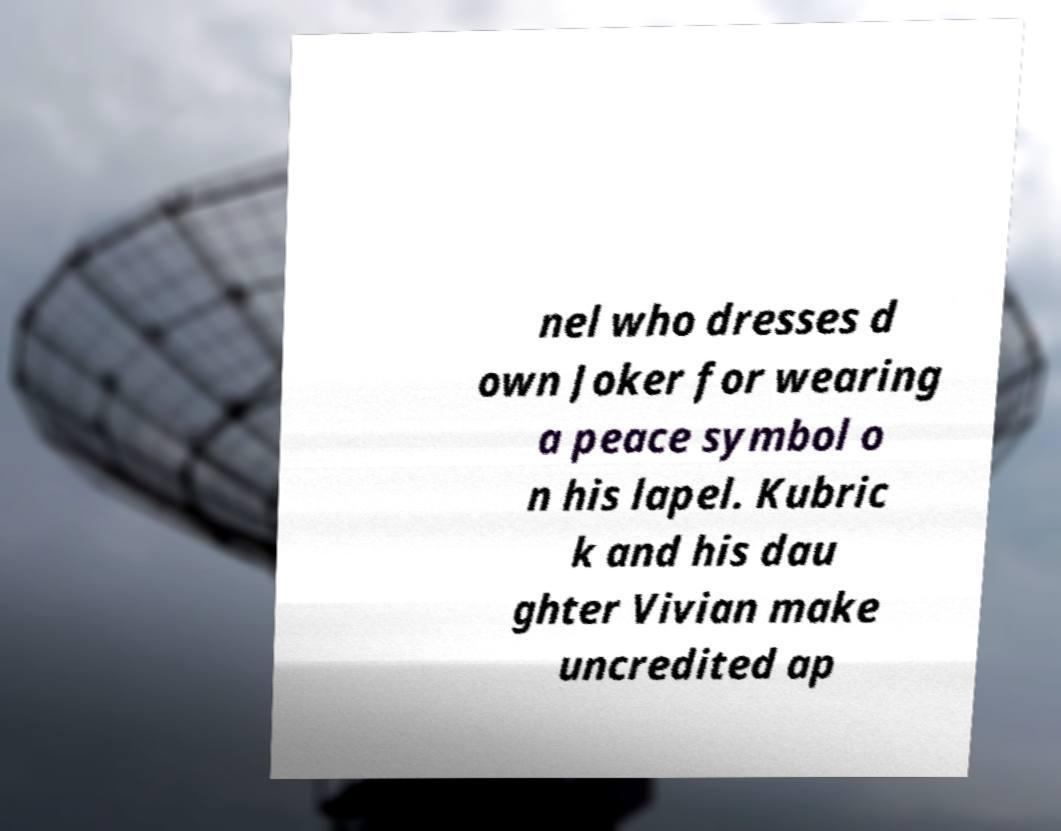Please read and relay the text visible in this image. What does it say? nel who dresses d own Joker for wearing a peace symbol o n his lapel. Kubric k and his dau ghter Vivian make uncredited ap 